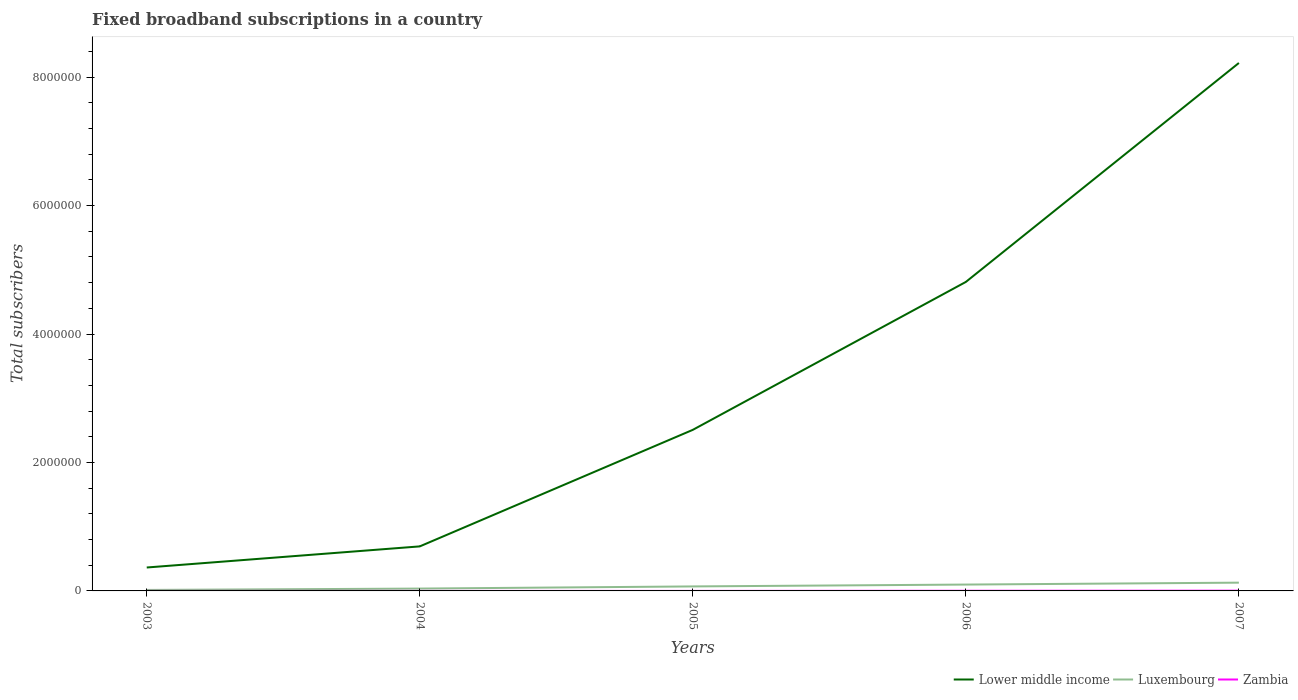Does the line corresponding to Luxembourg intersect with the line corresponding to Zambia?
Offer a terse response. No. Across all years, what is the maximum number of broadband subscriptions in Lower middle income?
Provide a short and direct response. 3.65e+05. What is the total number of broadband subscriptions in Zambia in the graph?
Offer a very short reply. -2089. What is the difference between the highest and the second highest number of broadband subscriptions in Lower middle income?
Make the answer very short. 7.86e+06. Are the values on the major ticks of Y-axis written in scientific E-notation?
Your answer should be very brief. No. How many legend labels are there?
Your answer should be very brief. 3. What is the title of the graph?
Provide a short and direct response. Fixed broadband subscriptions in a country. What is the label or title of the Y-axis?
Your answer should be very brief. Total subscribers. What is the Total subscribers of Lower middle income in 2003?
Provide a succinct answer. 3.65e+05. What is the Total subscribers of Luxembourg in 2003?
Make the answer very short. 1.54e+04. What is the Total subscribers of Zambia in 2003?
Give a very brief answer. 91. What is the Total subscribers in Lower middle income in 2004?
Your response must be concise. 6.93e+05. What is the Total subscribers in Luxembourg in 2004?
Your response must be concise. 3.65e+04. What is the Total subscribers of Zambia in 2004?
Make the answer very short. 250. What is the Total subscribers in Lower middle income in 2005?
Offer a terse response. 2.51e+06. What is the Total subscribers of Luxembourg in 2005?
Your answer should be very brief. 7.01e+04. What is the Total subscribers of Zambia in 2005?
Keep it short and to the point. 250. What is the Total subscribers in Lower middle income in 2006?
Make the answer very short. 4.81e+06. What is the Total subscribers of Luxembourg in 2006?
Keep it short and to the point. 9.89e+04. What is the Total subscribers of Zambia in 2006?
Provide a succinct answer. 2339. What is the Total subscribers of Lower middle income in 2007?
Provide a succinct answer. 8.22e+06. What is the Total subscribers of Luxembourg in 2007?
Offer a terse response. 1.29e+05. What is the Total subscribers of Zambia in 2007?
Keep it short and to the point. 4000. Across all years, what is the maximum Total subscribers in Lower middle income?
Keep it short and to the point. 8.22e+06. Across all years, what is the maximum Total subscribers of Luxembourg?
Give a very brief answer. 1.29e+05. Across all years, what is the maximum Total subscribers of Zambia?
Give a very brief answer. 4000. Across all years, what is the minimum Total subscribers in Lower middle income?
Your answer should be compact. 3.65e+05. Across all years, what is the minimum Total subscribers of Luxembourg?
Your answer should be compact. 1.54e+04. Across all years, what is the minimum Total subscribers of Zambia?
Provide a short and direct response. 91. What is the total Total subscribers in Lower middle income in the graph?
Ensure brevity in your answer.  1.66e+07. What is the total Total subscribers in Luxembourg in the graph?
Provide a short and direct response. 3.50e+05. What is the total Total subscribers in Zambia in the graph?
Make the answer very short. 6930. What is the difference between the Total subscribers in Lower middle income in 2003 and that in 2004?
Make the answer very short. -3.29e+05. What is the difference between the Total subscribers of Luxembourg in 2003 and that in 2004?
Your answer should be compact. -2.11e+04. What is the difference between the Total subscribers of Zambia in 2003 and that in 2004?
Provide a succinct answer. -159. What is the difference between the Total subscribers in Lower middle income in 2003 and that in 2005?
Keep it short and to the point. -2.14e+06. What is the difference between the Total subscribers of Luxembourg in 2003 and that in 2005?
Offer a terse response. -5.47e+04. What is the difference between the Total subscribers of Zambia in 2003 and that in 2005?
Provide a succinct answer. -159. What is the difference between the Total subscribers in Lower middle income in 2003 and that in 2006?
Keep it short and to the point. -4.45e+06. What is the difference between the Total subscribers in Luxembourg in 2003 and that in 2006?
Give a very brief answer. -8.36e+04. What is the difference between the Total subscribers in Zambia in 2003 and that in 2006?
Ensure brevity in your answer.  -2248. What is the difference between the Total subscribers in Lower middle income in 2003 and that in 2007?
Offer a very short reply. -7.86e+06. What is the difference between the Total subscribers of Luxembourg in 2003 and that in 2007?
Provide a short and direct response. -1.13e+05. What is the difference between the Total subscribers in Zambia in 2003 and that in 2007?
Your answer should be very brief. -3909. What is the difference between the Total subscribers in Lower middle income in 2004 and that in 2005?
Provide a succinct answer. -1.81e+06. What is the difference between the Total subscribers of Luxembourg in 2004 and that in 2005?
Your response must be concise. -3.36e+04. What is the difference between the Total subscribers of Zambia in 2004 and that in 2005?
Ensure brevity in your answer.  0. What is the difference between the Total subscribers in Lower middle income in 2004 and that in 2006?
Ensure brevity in your answer.  -4.12e+06. What is the difference between the Total subscribers of Luxembourg in 2004 and that in 2006?
Your response must be concise. -6.24e+04. What is the difference between the Total subscribers of Zambia in 2004 and that in 2006?
Provide a succinct answer. -2089. What is the difference between the Total subscribers of Lower middle income in 2004 and that in 2007?
Your answer should be very brief. -7.53e+06. What is the difference between the Total subscribers in Luxembourg in 2004 and that in 2007?
Offer a terse response. -9.22e+04. What is the difference between the Total subscribers in Zambia in 2004 and that in 2007?
Your answer should be compact. -3750. What is the difference between the Total subscribers in Lower middle income in 2005 and that in 2006?
Ensure brevity in your answer.  -2.30e+06. What is the difference between the Total subscribers in Luxembourg in 2005 and that in 2006?
Give a very brief answer. -2.88e+04. What is the difference between the Total subscribers of Zambia in 2005 and that in 2006?
Make the answer very short. -2089. What is the difference between the Total subscribers in Lower middle income in 2005 and that in 2007?
Provide a succinct answer. -5.71e+06. What is the difference between the Total subscribers of Luxembourg in 2005 and that in 2007?
Offer a very short reply. -5.86e+04. What is the difference between the Total subscribers in Zambia in 2005 and that in 2007?
Ensure brevity in your answer.  -3750. What is the difference between the Total subscribers of Lower middle income in 2006 and that in 2007?
Provide a succinct answer. -3.41e+06. What is the difference between the Total subscribers in Luxembourg in 2006 and that in 2007?
Keep it short and to the point. -2.98e+04. What is the difference between the Total subscribers of Zambia in 2006 and that in 2007?
Keep it short and to the point. -1661. What is the difference between the Total subscribers of Lower middle income in 2003 and the Total subscribers of Luxembourg in 2004?
Your response must be concise. 3.28e+05. What is the difference between the Total subscribers in Lower middle income in 2003 and the Total subscribers in Zambia in 2004?
Offer a terse response. 3.64e+05. What is the difference between the Total subscribers in Luxembourg in 2003 and the Total subscribers in Zambia in 2004?
Your answer should be very brief. 1.51e+04. What is the difference between the Total subscribers of Lower middle income in 2003 and the Total subscribers of Luxembourg in 2005?
Keep it short and to the point. 2.95e+05. What is the difference between the Total subscribers of Lower middle income in 2003 and the Total subscribers of Zambia in 2005?
Keep it short and to the point. 3.64e+05. What is the difference between the Total subscribers of Luxembourg in 2003 and the Total subscribers of Zambia in 2005?
Ensure brevity in your answer.  1.51e+04. What is the difference between the Total subscribers of Lower middle income in 2003 and the Total subscribers of Luxembourg in 2006?
Your response must be concise. 2.66e+05. What is the difference between the Total subscribers of Lower middle income in 2003 and the Total subscribers of Zambia in 2006?
Your answer should be very brief. 3.62e+05. What is the difference between the Total subscribers in Luxembourg in 2003 and the Total subscribers in Zambia in 2006?
Make the answer very short. 1.30e+04. What is the difference between the Total subscribers of Lower middle income in 2003 and the Total subscribers of Luxembourg in 2007?
Your response must be concise. 2.36e+05. What is the difference between the Total subscribers of Lower middle income in 2003 and the Total subscribers of Zambia in 2007?
Make the answer very short. 3.61e+05. What is the difference between the Total subscribers of Luxembourg in 2003 and the Total subscribers of Zambia in 2007?
Ensure brevity in your answer.  1.14e+04. What is the difference between the Total subscribers of Lower middle income in 2004 and the Total subscribers of Luxembourg in 2005?
Offer a terse response. 6.23e+05. What is the difference between the Total subscribers of Lower middle income in 2004 and the Total subscribers of Zambia in 2005?
Provide a succinct answer. 6.93e+05. What is the difference between the Total subscribers in Luxembourg in 2004 and the Total subscribers in Zambia in 2005?
Give a very brief answer. 3.62e+04. What is the difference between the Total subscribers of Lower middle income in 2004 and the Total subscribers of Luxembourg in 2006?
Ensure brevity in your answer.  5.95e+05. What is the difference between the Total subscribers in Lower middle income in 2004 and the Total subscribers in Zambia in 2006?
Provide a succinct answer. 6.91e+05. What is the difference between the Total subscribers of Luxembourg in 2004 and the Total subscribers of Zambia in 2006?
Ensure brevity in your answer.  3.42e+04. What is the difference between the Total subscribers in Lower middle income in 2004 and the Total subscribers in Luxembourg in 2007?
Offer a terse response. 5.65e+05. What is the difference between the Total subscribers of Lower middle income in 2004 and the Total subscribers of Zambia in 2007?
Ensure brevity in your answer.  6.89e+05. What is the difference between the Total subscribers of Luxembourg in 2004 and the Total subscribers of Zambia in 2007?
Offer a very short reply. 3.25e+04. What is the difference between the Total subscribers of Lower middle income in 2005 and the Total subscribers of Luxembourg in 2006?
Give a very brief answer. 2.41e+06. What is the difference between the Total subscribers in Lower middle income in 2005 and the Total subscribers in Zambia in 2006?
Your answer should be compact. 2.51e+06. What is the difference between the Total subscribers of Luxembourg in 2005 and the Total subscribers of Zambia in 2006?
Offer a very short reply. 6.78e+04. What is the difference between the Total subscribers of Lower middle income in 2005 and the Total subscribers of Luxembourg in 2007?
Your response must be concise. 2.38e+06. What is the difference between the Total subscribers in Lower middle income in 2005 and the Total subscribers in Zambia in 2007?
Give a very brief answer. 2.50e+06. What is the difference between the Total subscribers in Luxembourg in 2005 and the Total subscribers in Zambia in 2007?
Your answer should be compact. 6.61e+04. What is the difference between the Total subscribers of Lower middle income in 2006 and the Total subscribers of Luxembourg in 2007?
Your answer should be compact. 4.68e+06. What is the difference between the Total subscribers in Lower middle income in 2006 and the Total subscribers in Zambia in 2007?
Provide a short and direct response. 4.81e+06. What is the difference between the Total subscribers in Luxembourg in 2006 and the Total subscribers in Zambia in 2007?
Your response must be concise. 9.49e+04. What is the average Total subscribers in Lower middle income per year?
Provide a short and direct response. 3.32e+06. What is the average Total subscribers in Luxembourg per year?
Offer a very short reply. 6.99e+04. What is the average Total subscribers in Zambia per year?
Keep it short and to the point. 1386. In the year 2003, what is the difference between the Total subscribers in Lower middle income and Total subscribers in Luxembourg?
Your response must be concise. 3.49e+05. In the year 2003, what is the difference between the Total subscribers in Lower middle income and Total subscribers in Zambia?
Your answer should be compact. 3.65e+05. In the year 2003, what is the difference between the Total subscribers of Luxembourg and Total subscribers of Zambia?
Keep it short and to the point. 1.53e+04. In the year 2004, what is the difference between the Total subscribers of Lower middle income and Total subscribers of Luxembourg?
Provide a short and direct response. 6.57e+05. In the year 2004, what is the difference between the Total subscribers in Lower middle income and Total subscribers in Zambia?
Give a very brief answer. 6.93e+05. In the year 2004, what is the difference between the Total subscribers in Luxembourg and Total subscribers in Zambia?
Your answer should be very brief. 3.62e+04. In the year 2005, what is the difference between the Total subscribers in Lower middle income and Total subscribers in Luxembourg?
Your answer should be compact. 2.44e+06. In the year 2005, what is the difference between the Total subscribers in Lower middle income and Total subscribers in Zambia?
Provide a short and direct response. 2.51e+06. In the year 2005, what is the difference between the Total subscribers of Luxembourg and Total subscribers of Zambia?
Your answer should be very brief. 6.98e+04. In the year 2006, what is the difference between the Total subscribers of Lower middle income and Total subscribers of Luxembourg?
Ensure brevity in your answer.  4.71e+06. In the year 2006, what is the difference between the Total subscribers in Lower middle income and Total subscribers in Zambia?
Make the answer very short. 4.81e+06. In the year 2006, what is the difference between the Total subscribers of Luxembourg and Total subscribers of Zambia?
Your response must be concise. 9.66e+04. In the year 2007, what is the difference between the Total subscribers in Lower middle income and Total subscribers in Luxembourg?
Your answer should be compact. 8.09e+06. In the year 2007, what is the difference between the Total subscribers in Lower middle income and Total subscribers in Zambia?
Keep it short and to the point. 8.22e+06. In the year 2007, what is the difference between the Total subscribers of Luxembourg and Total subscribers of Zambia?
Ensure brevity in your answer.  1.25e+05. What is the ratio of the Total subscribers of Lower middle income in 2003 to that in 2004?
Give a very brief answer. 0.53. What is the ratio of the Total subscribers in Luxembourg in 2003 to that in 2004?
Your answer should be very brief. 0.42. What is the ratio of the Total subscribers of Zambia in 2003 to that in 2004?
Your answer should be compact. 0.36. What is the ratio of the Total subscribers of Lower middle income in 2003 to that in 2005?
Give a very brief answer. 0.15. What is the ratio of the Total subscribers of Luxembourg in 2003 to that in 2005?
Offer a terse response. 0.22. What is the ratio of the Total subscribers in Zambia in 2003 to that in 2005?
Your answer should be compact. 0.36. What is the ratio of the Total subscribers in Lower middle income in 2003 to that in 2006?
Your answer should be compact. 0.08. What is the ratio of the Total subscribers in Luxembourg in 2003 to that in 2006?
Your answer should be very brief. 0.16. What is the ratio of the Total subscribers in Zambia in 2003 to that in 2006?
Give a very brief answer. 0.04. What is the ratio of the Total subscribers of Lower middle income in 2003 to that in 2007?
Keep it short and to the point. 0.04. What is the ratio of the Total subscribers of Luxembourg in 2003 to that in 2007?
Offer a very short reply. 0.12. What is the ratio of the Total subscribers of Zambia in 2003 to that in 2007?
Provide a short and direct response. 0.02. What is the ratio of the Total subscribers of Lower middle income in 2004 to that in 2005?
Make the answer very short. 0.28. What is the ratio of the Total subscribers of Luxembourg in 2004 to that in 2005?
Your answer should be compact. 0.52. What is the ratio of the Total subscribers of Zambia in 2004 to that in 2005?
Your answer should be compact. 1. What is the ratio of the Total subscribers of Lower middle income in 2004 to that in 2006?
Your answer should be very brief. 0.14. What is the ratio of the Total subscribers in Luxembourg in 2004 to that in 2006?
Offer a very short reply. 0.37. What is the ratio of the Total subscribers in Zambia in 2004 to that in 2006?
Offer a terse response. 0.11. What is the ratio of the Total subscribers in Lower middle income in 2004 to that in 2007?
Your answer should be very brief. 0.08. What is the ratio of the Total subscribers of Luxembourg in 2004 to that in 2007?
Offer a terse response. 0.28. What is the ratio of the Total subscribers in Zambia in 2004 to that in 2007?
Keep it short and to the point. 0.06. What is the ratio of the Total subscribers in Lower middle income in 2005 to that in 2006?
Offer a terse response. 0.52. What is the ratio of the Total subscribers of Luxembourg in 2005 to that in 2006?
Offer a terse response. 0.71. What is the ratio of the Total subscribers in Zambia in 2005 to that in 2006?
Ensure brevity in your answer.  0.11. What is the ratio of the Total subscribers in Lower middle income in 2005 to that in 2007?
Your response must be concise. 0.31. What is the ratio of the Total subscribers of Luxembourg in 2005 to that in 2007?
Your response must be concise. 0.54. What is the ratio of the Total subscribers in Zambia in 2005 to that in 2007?
Offer a terse response. 0.06. What is the ratio of the Total subscribers in Lower middle income in 2006 to that in 2007?
Provide a short and direct response. 0.59. What is the ratio of the Total subscribers in Luxembourg in 2006 to that in 2007?
Your answer should be very brief. 0.77. What is the ratio of the Total subscribers in Zambia in 2006 to that in 2007?
Your answer should be compact. 0.58. What is the difference between the highest and the second highest Total subscribers of Lower middle income?
Ensure brevity in your answer.  3.41e+06. What is the difference between the highest and the second highest Total subscribers of Luxembourg?
Keep it short and to the point. 2.98e+04. What is the difference between the highest and the second highest Total subscribers in Zambia?
Provide a short and direct response. 1661. What is the difference between the highest and the lowest Total subscribers of Lower middle income?
Your response must be concise. 7.86e+06. What is the difference between the highest and the lowest Total subscribers in Luxembourg?
Give a very brief answer. 1.13e+05. What is the difference between the highest and the lowest Total subscribers in Zambia?
Make the answer very short. 3909. 